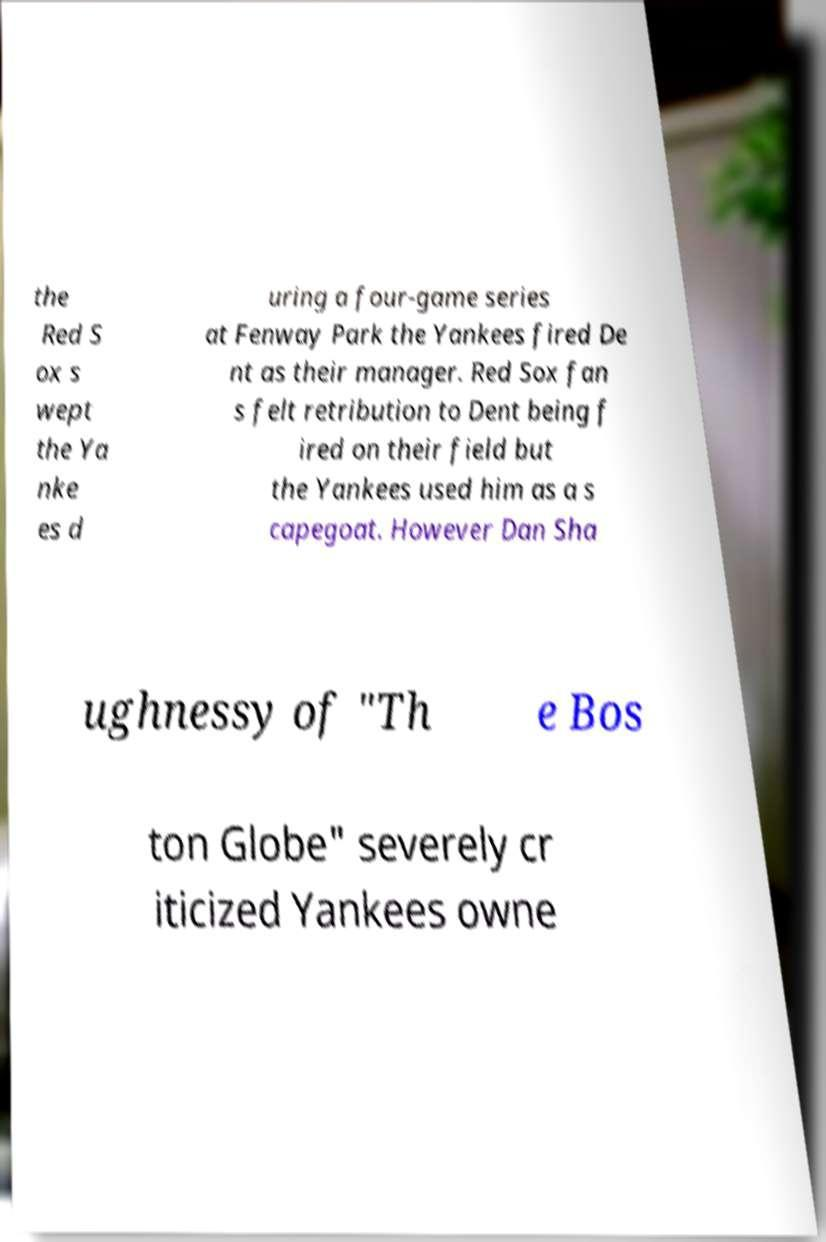Could you extract and type out the text from this image? the Red S ox s wept the Ya nke es d uring a four-game series at Fenway Park the Yankees fired De nt as their manager. Red Sox fan s felt retribution to Dent being f ired on their field but the Yankees used him as a s capegoat. However Dan Sha ughnessy of "Th e Bos ton Globe" severely cr iticized Yankees owne 